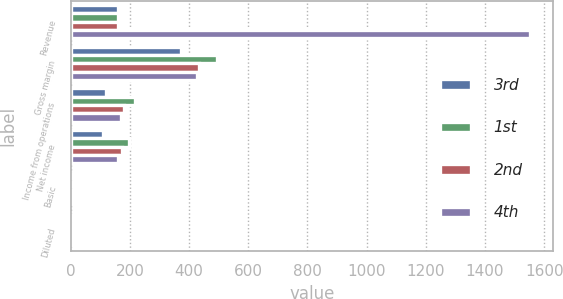<chart> <loc_0><loc_0><loc_500><loc_500><stacked_bar_chart><ecel><fcel>Revenue<fcel>Gross margin<fcel>Income from operations<fcel>Net income<fcel>Basic<fcel>Diluted<nl><fcel>3rd<fcel>160<fcel>372<fcel>119<fcel>110<fcel>0.27<fcel>0.24<nl><fcel>1st<fcel>160<fcel>493<fcel>219<fcel>198<fcel>0.49<fcel>0.43<nl><fcel>2nd<fcel>160<fcel>434<fcel>182<fcel>174<fcel>0.41<fcel>0.37<nl><fcel>4th<fcel>1553<fcel>428<fcel>171<fcel>160<fcel>0.37<fcel>0.33<nl></chart> 